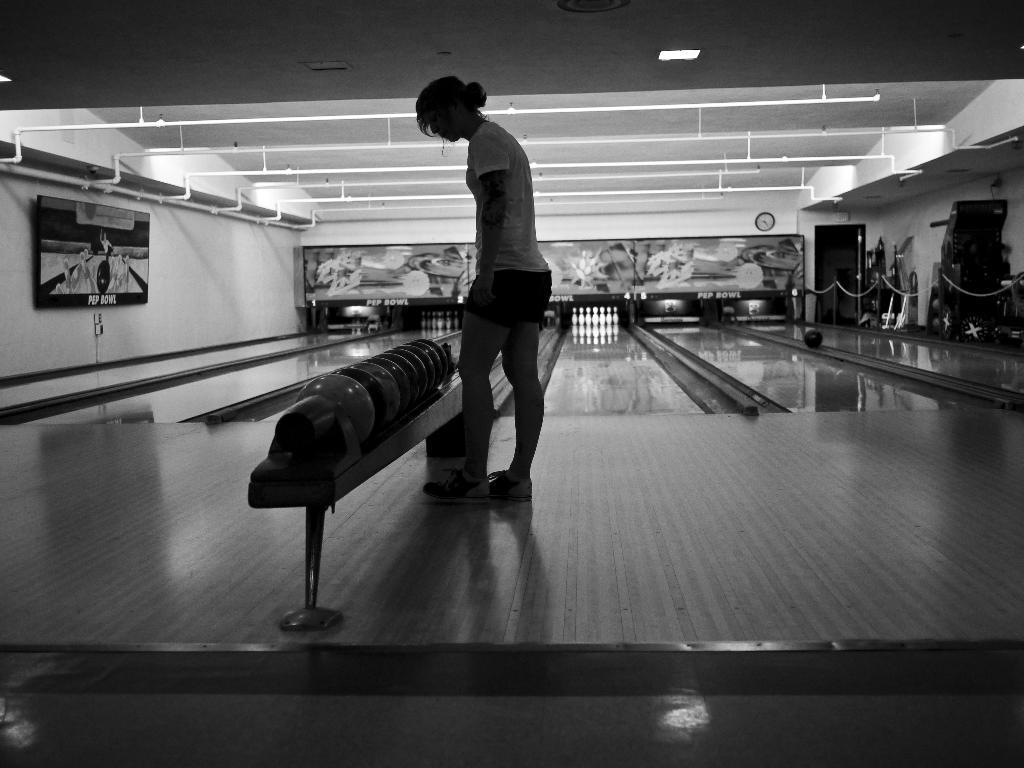In one or two sentences, can you explain what this image depicts? In this picture we can see a woman standing in the front. Beside there is a bowl rack. Behind we can see the white color bowling pins. On the top ceiling we can see the pipe frame and some lights. 